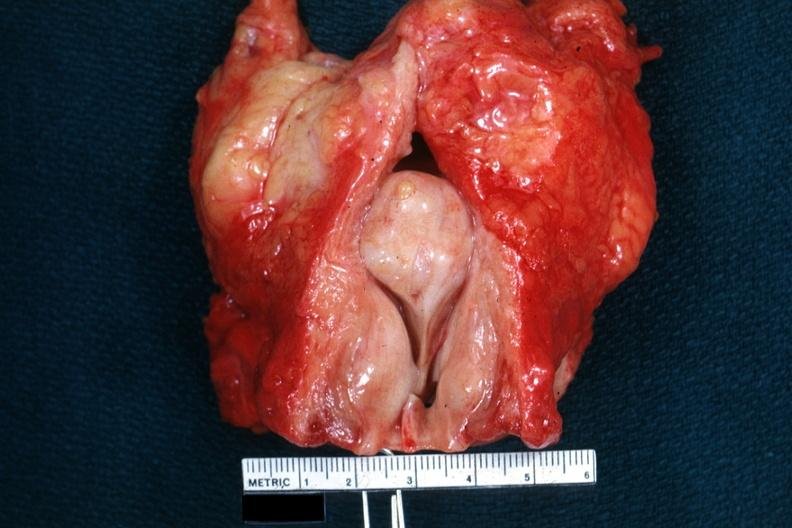s prostate present?
Answer the question using a single word or phrase. Yes 